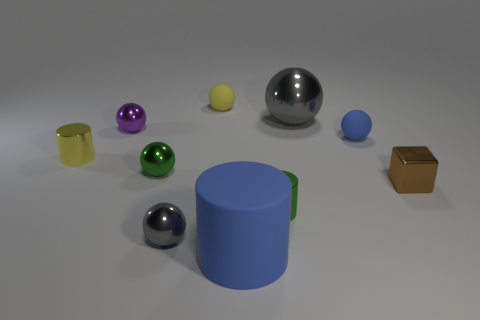What material is the thing that is in front of the tiny yellow metal object and on the right side of the big ball?
Make the answer very short. Metal. Are there any cylinders that are in front of the cylinder to the left of the yellow matte thing?
Offer a terse response. Yes. Is the small brown cube made of the same material as the large gray sphere?
Ensure brevity in your answer.  Yes. What is the shape of the object that is both in front of the green metal cylinder and left of the small yellow matte thing?
Ensure brevity in your answer.  Sphere. How big is the blue rubber thing to the right of the gray thing on the right side of the big blue thing?
Provide a short and direct response. Small. What number of tiny yellow shiny things have the same shape as the big blue rubber object?
Your answer should be very brief. 1. Is there anything else that has the same shape as the small brown metal thing?
Provide a succinct answer. No. Is there a large shiny cylinder of the same color as the metal cube?
Provide a succinct answer. No. Is the material of the large thing behind the metallic block the same as the cylinder that is left of the large blue thing?
Provide a short and direct response. Yes. The block has what color?
Your answer should be very brief. Brown. 